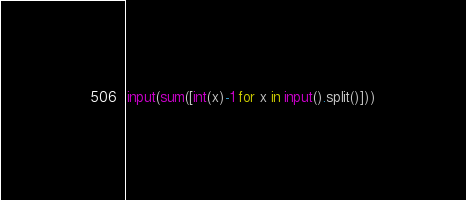Convert code to text. <code><loc_0><loc_0><loc_500><loc_500><_Python_>input(sum([int(x)-1 for x in input().split()]))</code> 